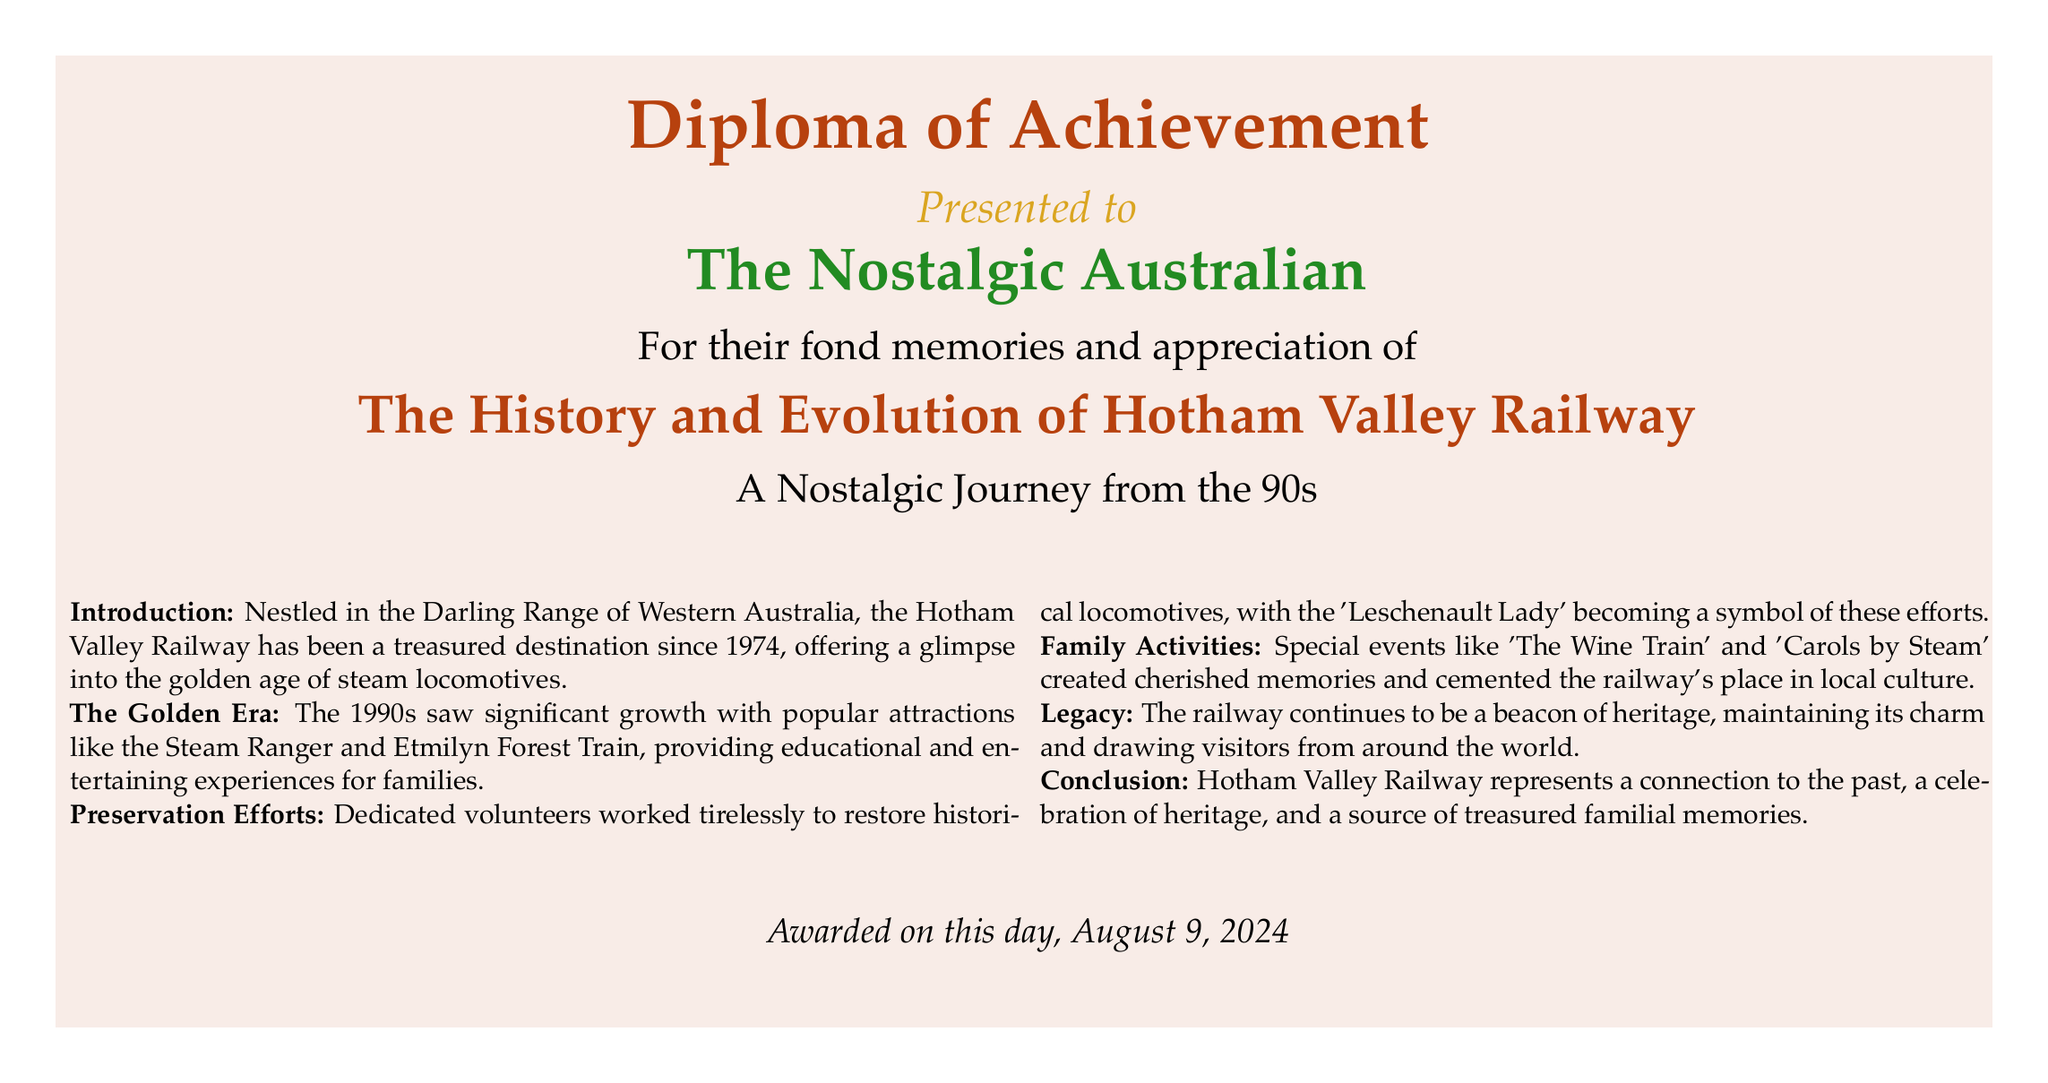What year was Hotham Valley Railway established? The establishment year is mentioned in the introduction as 1974.
Answer: 1974 What was a significant attraction in the 1990s? The document highlights the Steam Ranger and Etmilyn Forest Train as popular attractions during that decade.
Answer: Steam Ranger Who became a symbol of preservation efforts? The document states that 'Leschenault Lady' is recognized as a symbol of preservation efforts.
Answer: Leschenault Lady What special event is mentioned for families? The document lists 'Carols by Steam' as a special family-oriented event.
Answer: Carols by Steam What type of document is this? The visual elements and title suggest this is a diploma of achievement.
Answer: Diploma of Achievement In what region is the Hotham Valley Railway located? The document mentions the Darling Range of Western Australia as the location of the railway.
Answer: Darling Range What ongoing aspect does the railway represent? The conclusion notes that the railway continues to celebrate heritage and familial connections.
Answer: Heritage What color represents the title of the diploma? The document indicates the title color as rusty red.
Answer: Rusty red What is the purpose of the Hotham Valley Railway as stated in the conclusion? The conclusion describes the railway as a connection to the past and a source of treasured memories.
Answer: Connection to the past 